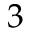Convert formula to latex. <formula><loc_0><loc_0><loc_500><loc_500>3</formula> 